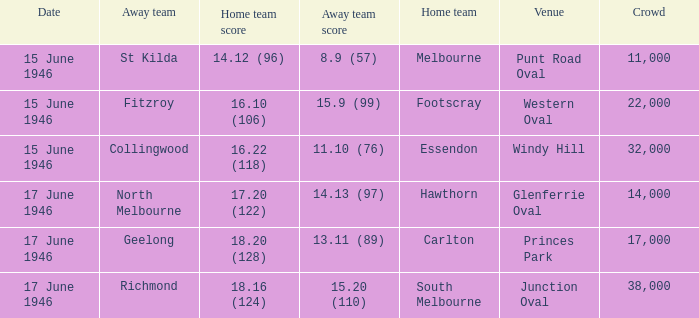On which date was a match conducted at windy hill? 15 June 1946. 